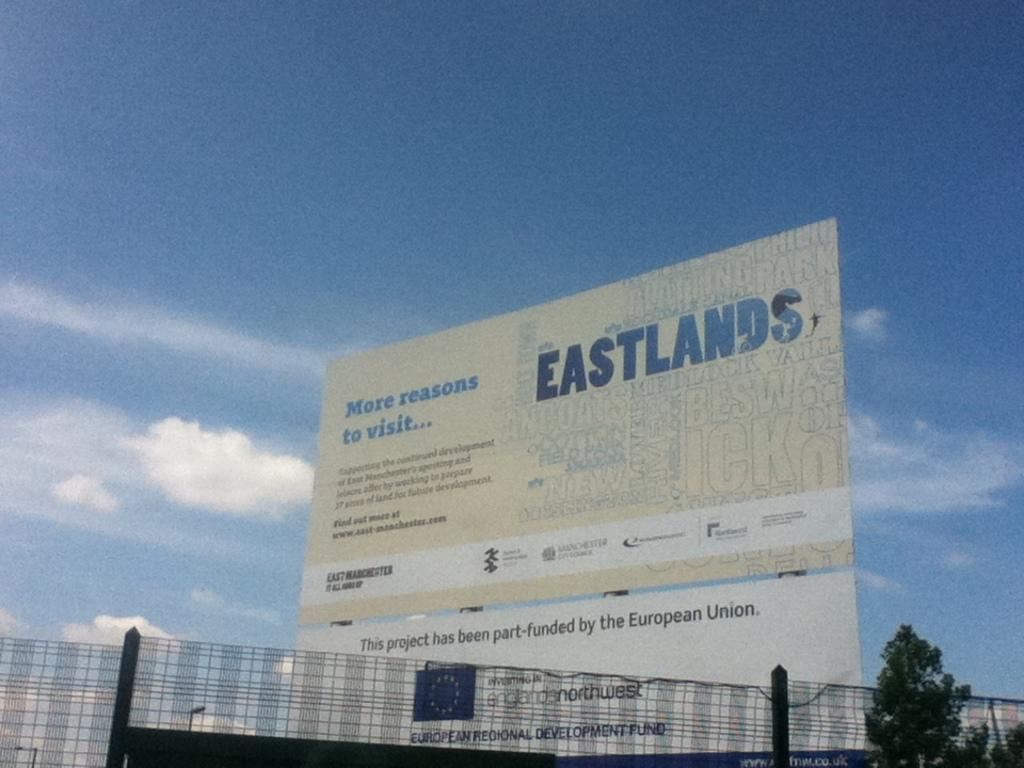<image>
Create a compact narrative representing the image presented. A large Eastlands billboard towers above an office building. 